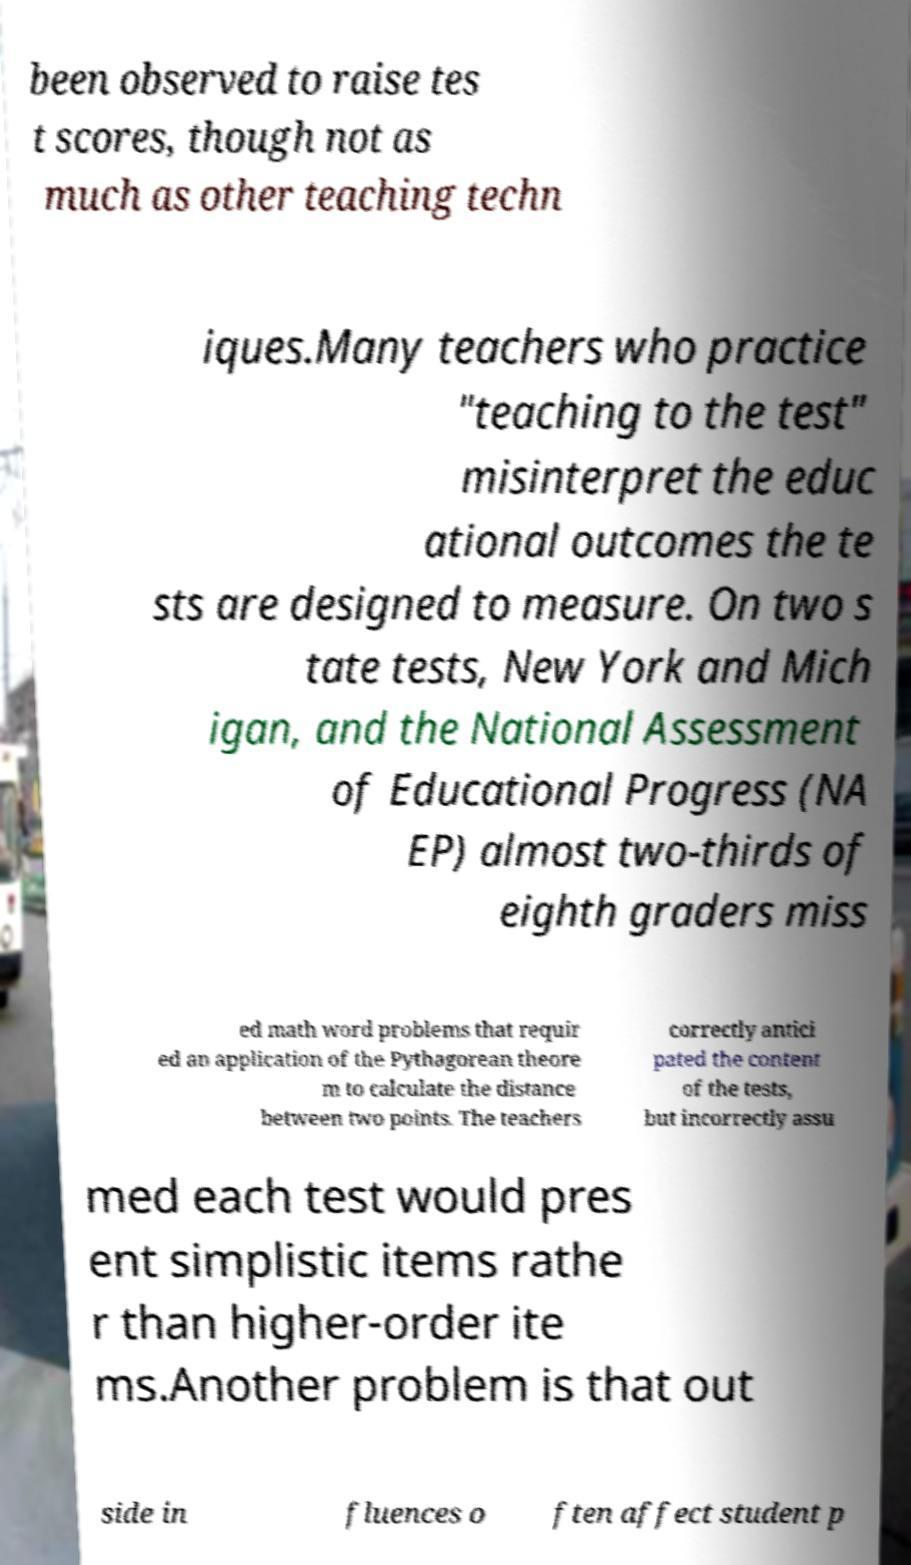What messages or text are displayed in this image? I need them in a readable, typed format. been observed to raise tes t scores, though not as much as other teaching techn iques.Many teachers who practice "teaching to the test" misinterpret the educ ational outcomes the te sts are designed to measure. On two s tate tests, New York and Mich igan, and the National Assessment of Educational Progress (NA EP) almost two-thirds of eighth graders miss ed math word problems that requir ed an application of the Pythagorean theore m to calculate the distance between two points. The teachers correctly antici pated the content of the tests, but incorrectly assu med each test would pres ent simplistic items rathe r than higher-order ite ms.Another problem is that out side in fluences o ften affect student p 